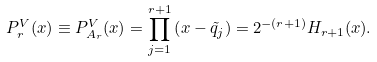<formula> <loc_0><loc_0><loc_500><loc_500>P _ { r } ^ { V } ( x ) \equiv P _ { A _ { r } } ^ { V } ( x ) = \prod _ { j = 1 } ^ { r + 1 } \left ( x - \tilde { q } _ { j } \right ) = 2 ^ { - ( r + 1 ) } H _ { r + 1 } ( x ) .</formula> 